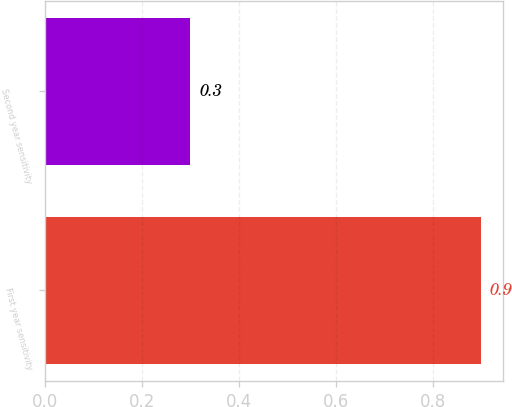Convert chart to OTSL. <chart><loc_0><loc_0><loc_500><loc_500><bar_chart><fcel>First year sensitivity<fcel>Second year sensitivity<nl><fcel>0.9<fcel>0.3<nl></chart> 